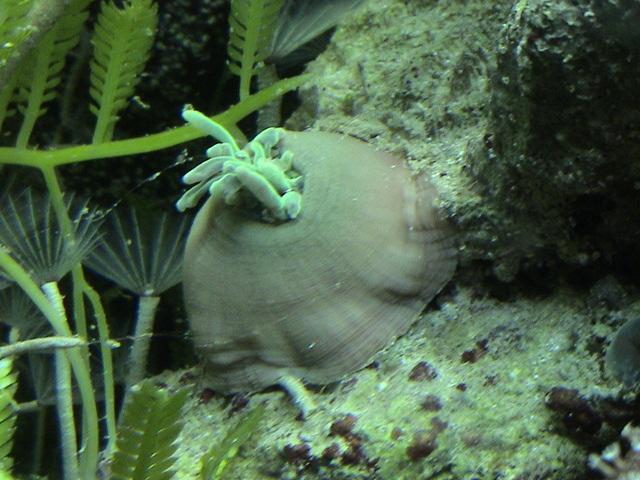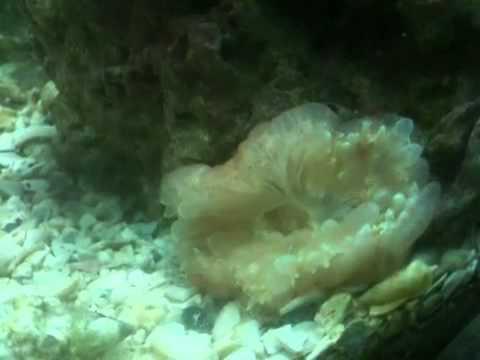The first image is the image on the left, the second image is the image on the right. Evaluate the accuracy of this statement regarding the images: "An image shows brownish anemone tendrils emerging from a rounded, inflated looking purplish sac.". Is it true? Answer yes or no. No. The first image is the image on the left, the second image is the image on the right. Given the left and right images, does the statement "Some elements of the coral are pink in at least one of the images." hold true? Answer yes or no. No. 